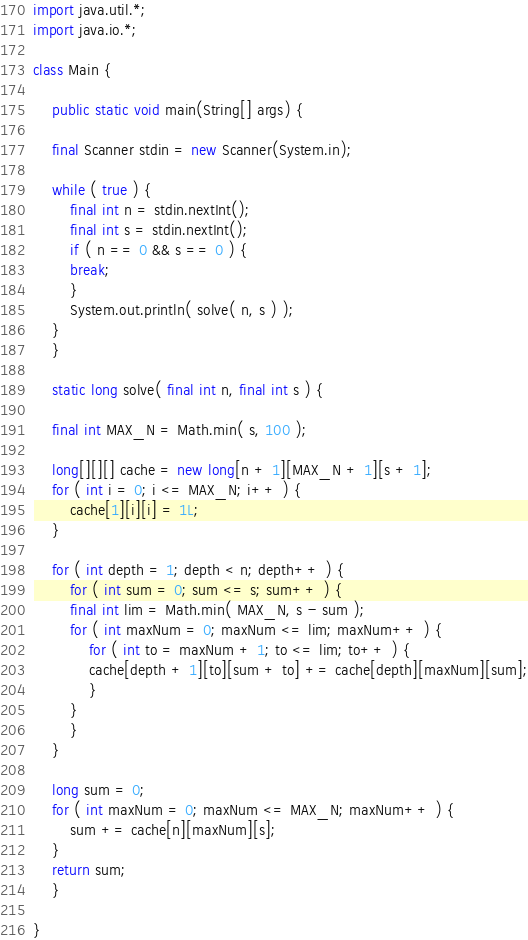<code> <loc_0><loc_0><loc_500><loc_500><_Java_>import java.util.*;
import java.io.*;

class Main {

    public static void main(String[] args) {

	final Scanner stdin = new Scanner(System.in);

	while ( true ) {
	    final int n = stdin.nextInt();
	    final int s = stdin.nextInt();
	    if ( n == 0 && s == 0 ) {
		break;
	    }
	    System.out.println( solve( n, s ) );
	}
    }

    static long solve( final int n, final int s ) {

	final int MAX_N = Math.min( s, 100 );
	
	long[][][] cache = new long[n + 1][MAX_N + 1][s + 1];
	for ( int i = 0; i <= MAX_N; i++ ) {
	    cache[1][i][i] = 1L;
	}
	
	for ( int depth = 1; depth < n; depth++ ) {
	    for ( int sum = 0; sum <= s; sum++ ) {
		final int lim = Math.min( MAX_N, s - sum );
		for ( int maxNum = 0; maxNum <= lim; maxNum++ ) {
		    for ( int to = maxNum + 1; to <= lim; to++ ) {
			cache[depth + 1][to][sum + to] += cache[depth][maxNum][sum];
		    }
		}
	    }
	}
	
	long sum = 0;
	for ( int maxNum = 0; maxNum <= MAX_N; maxNum++ ) {
	    sum += cache[n][maxNum][s];
	}
	return sum;	     
    }
    
}</code> 